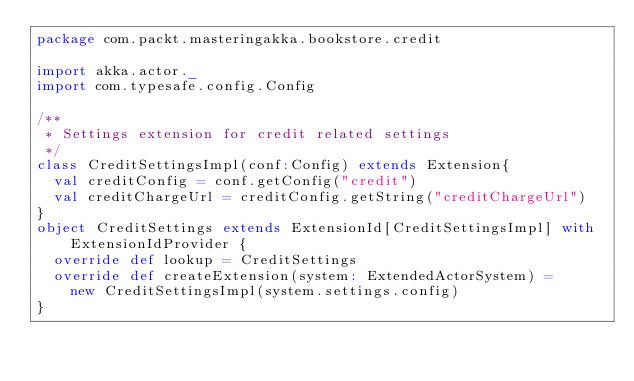<code> <loc_0><loc_0><loc_500><loc_500><_Scala_>package com.packt.masteringakka.bookstore.credit

import akka.actor._
import com.typesafe.config.Config

/**
 * Settings extension for credit related settings
 */
class CreditSettingsImpl(conf:Config) extends Extension{
  val creditConfig = conf.getConfig("credit")
  val creditChargeUrl = creditConfig.getString("creditChargeUrl")
}
object CreditSettings extends ExtensionId[CreditSettingsImpl] with ExtensionIdProvider { 
  override def lookup = CreditSettings 
  override def createExtension(system: ExtendedActorSystem) =
    new CreditSettingsImpl(system.settings.config)
}</code> 